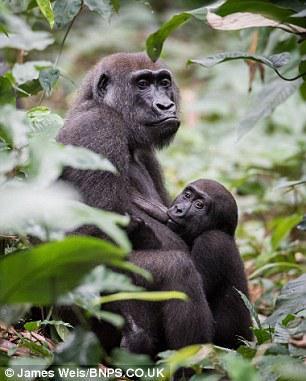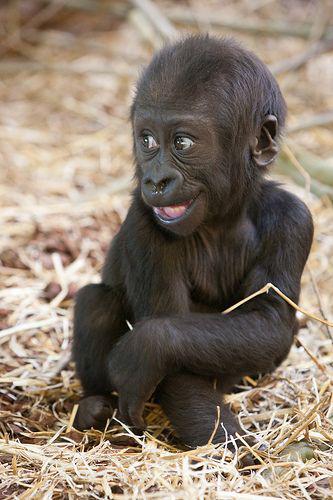The first image is the image on the left, the second image is the image on the right. For the images shown, is this caption "The left image shows a mother gorilla nursing her baby, sitting with her back to the left and her head raised and turned to gaze somewhat forward." true? Answer yes or no. Yes. The first image is the image on the left, the second image is the image on the right. Given the left and right images, does the statement "The gorilla in the image on the left is lying with the top of its head pointed left." hold true? Answer yes or no. No. 